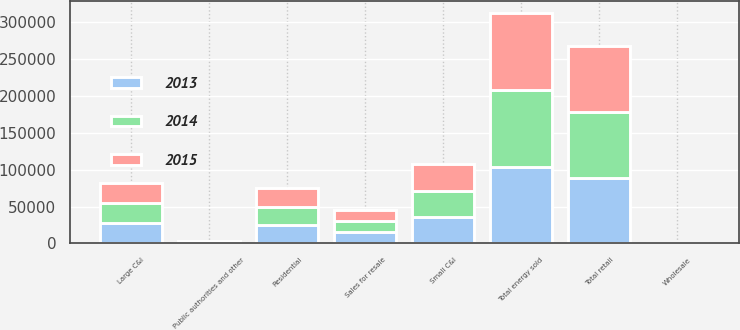<chart> <loc_0><loc_0><loc_500><loc_500><stacked_bar_chart><ecel><fcel>Residential<fcel>Large C&I<fcel>Small C&I<fcel>Public authorities and other<fcel>Total retail<fcel>Sales for resale<fcel>Total energy sold<fcel>Wholesale<nl><fcel>2013<fcel>24498<fcel>27719<fcel>35806<fcel>1071<fcel>89094<fcel>15283<fcel>104377<fcel>47<nl><fcel>2015<fcel>24857<fcel>27657<fcel>36022<fcel>1104<fcel>89640<fcel>14931<fcel>104571<fcel>44<nl><fcel>2014<fcel>25306<fcel>27206<fcel>35873<fcel>1098<fcel>89483<fcel>15065<fcel>104548<fcel>65<nl></chart> 